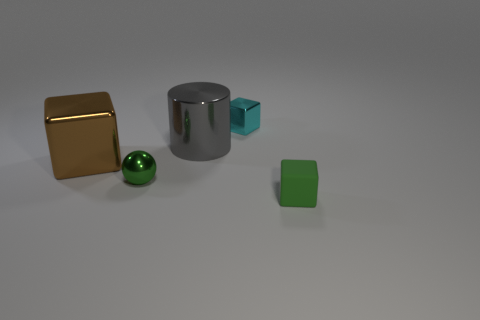Imagine these objects are part of a game. How could they be used? These objects could represent different elements in a strategy or puzzle game. For instance, the golden cube might symbolize a resource like gold, valuable for trade or advancement. The chrome cylinder could serve as a futuristic 'power core' needed to unlock new levels or technology. The green sphere may act as an orb with special abilities, while the green cube could be a wild card piece, its function changing depending on circumstance or placement within the game. 